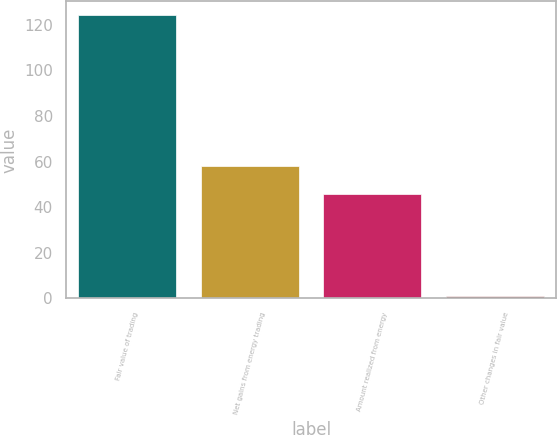<chart> <loc_0><loc_0><loc_500><loc_500><bar_chart><fcel>Fair value of trading<fcel>Net gains from energy trading<fcel>Amount realized from energy<fcel>Other changes in fair value<nl><fcel>124.1<fcel>58.1<fcel>46<fcel>1<nl></chart> 